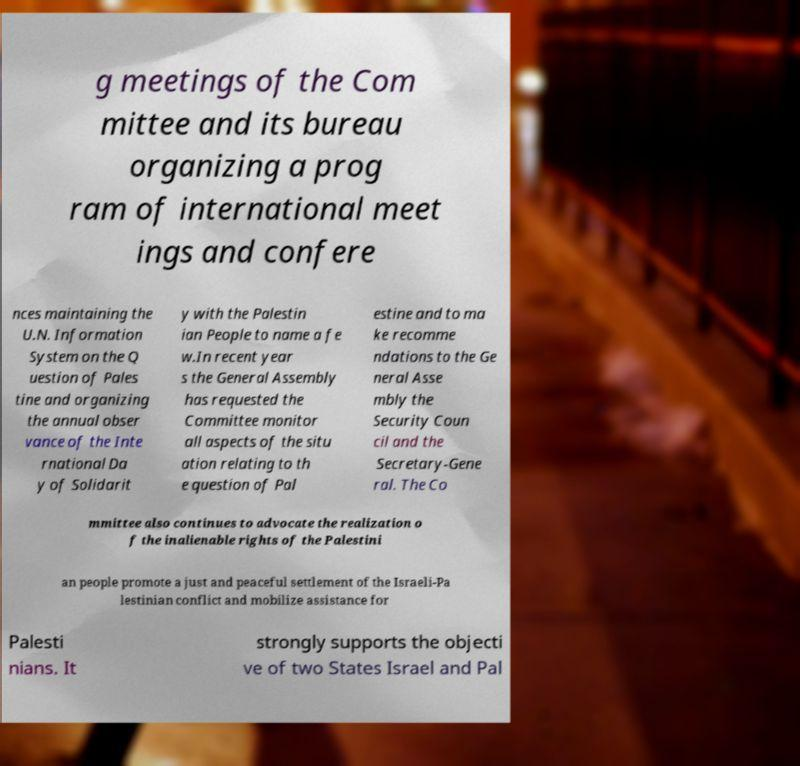Can you accurately transcribe the text from the provided image for me? g meetings of the Com mittee and its bureau organizing a prog ram of international meet ings and confere nces maintaining the U.N. Information System on the Q uestion of Pales tine and organizing the annual obser vance of the Inte rnational Da y of Solidarit y with the Palestin ian People to name a fe w.In recent year s the General Assembly has requested the Committee monitor all aspects of the situ ation relating to th e question of Pal estine and to ma ke recomme ndations to the Ge neral Asse mbly the Security Coun cil and the Secretary-Gene ral. The Co mmittee also continues to advocate the realization o f the inalienable rights of the Palestini an people promote a just and peaceful settlement of the Israeli-Pa lestinian conflict and mobilize assistance for Palesti nians. It strongly supports the objecti ve of two States Israel and Pal 